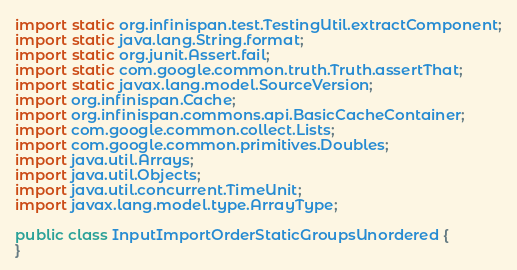Convert code to text. <code><loc_0><loc_0><loc_500><loc_500><_Java_>import static org.infinispan.test.TestingUtil.extractComponent;
import static java.lang.String.format;
import static org.junit.Assert.fail;
import static com.google.common.truth.Truth.assertThat;
import static javax.lang.model.SourceVersion;
import org.infinispan.Cache;
import org.infinispan.commons.api.BasicCacheContainer;
import com.google.common.collect.Lists;
import com.google.common.primitives.Doubles;
import java.util.Arrays;
import java.util.Objects;
import java.util.concurrent.TimeUnit;
import javax.lang.model.type.ArrayType;

public class InputImportOrderStaticGroupsUnordered {
}
</code> 